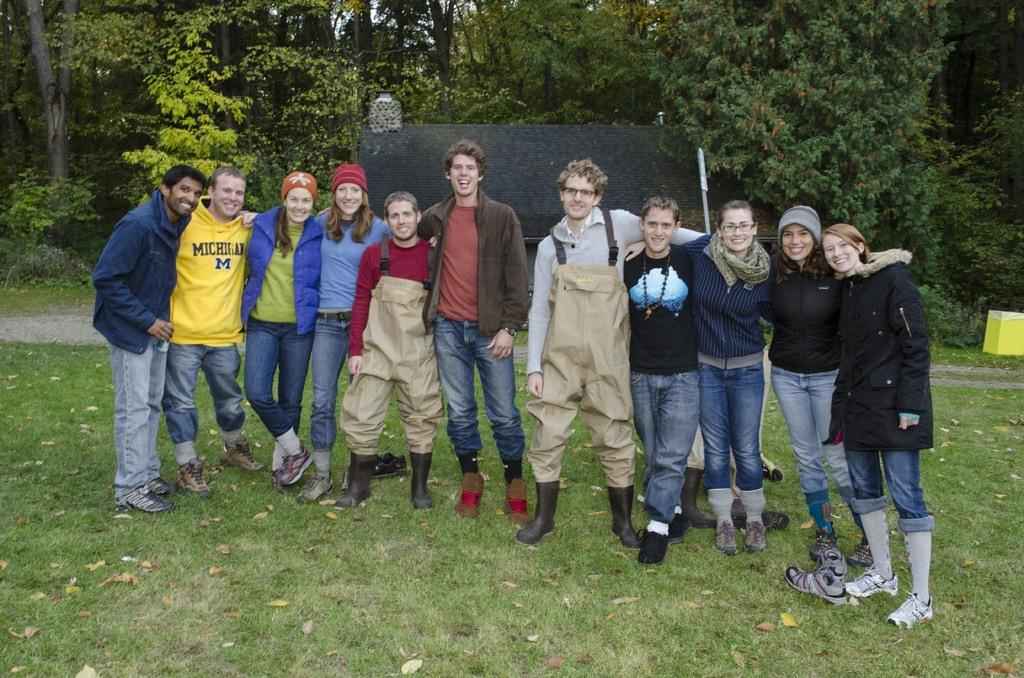How many people are in the group in the image? There is a group of people in the image, but the exact number is not specified. What is the facial expression of some people in the group? Some people in the group are smiling. What type of surface are the people standing on? The people are standing on the grass. What can be seen in the background of the image? There are trees in the background of the image. Can you see any roses in the hands of the people in the image? There is no mention of roses in the image, so it cannot be determined if any are present. What type of drink is being shared among the group in the image? There is no drink visible in the image, so it cannot be determined what, if any, drink is being shared. 